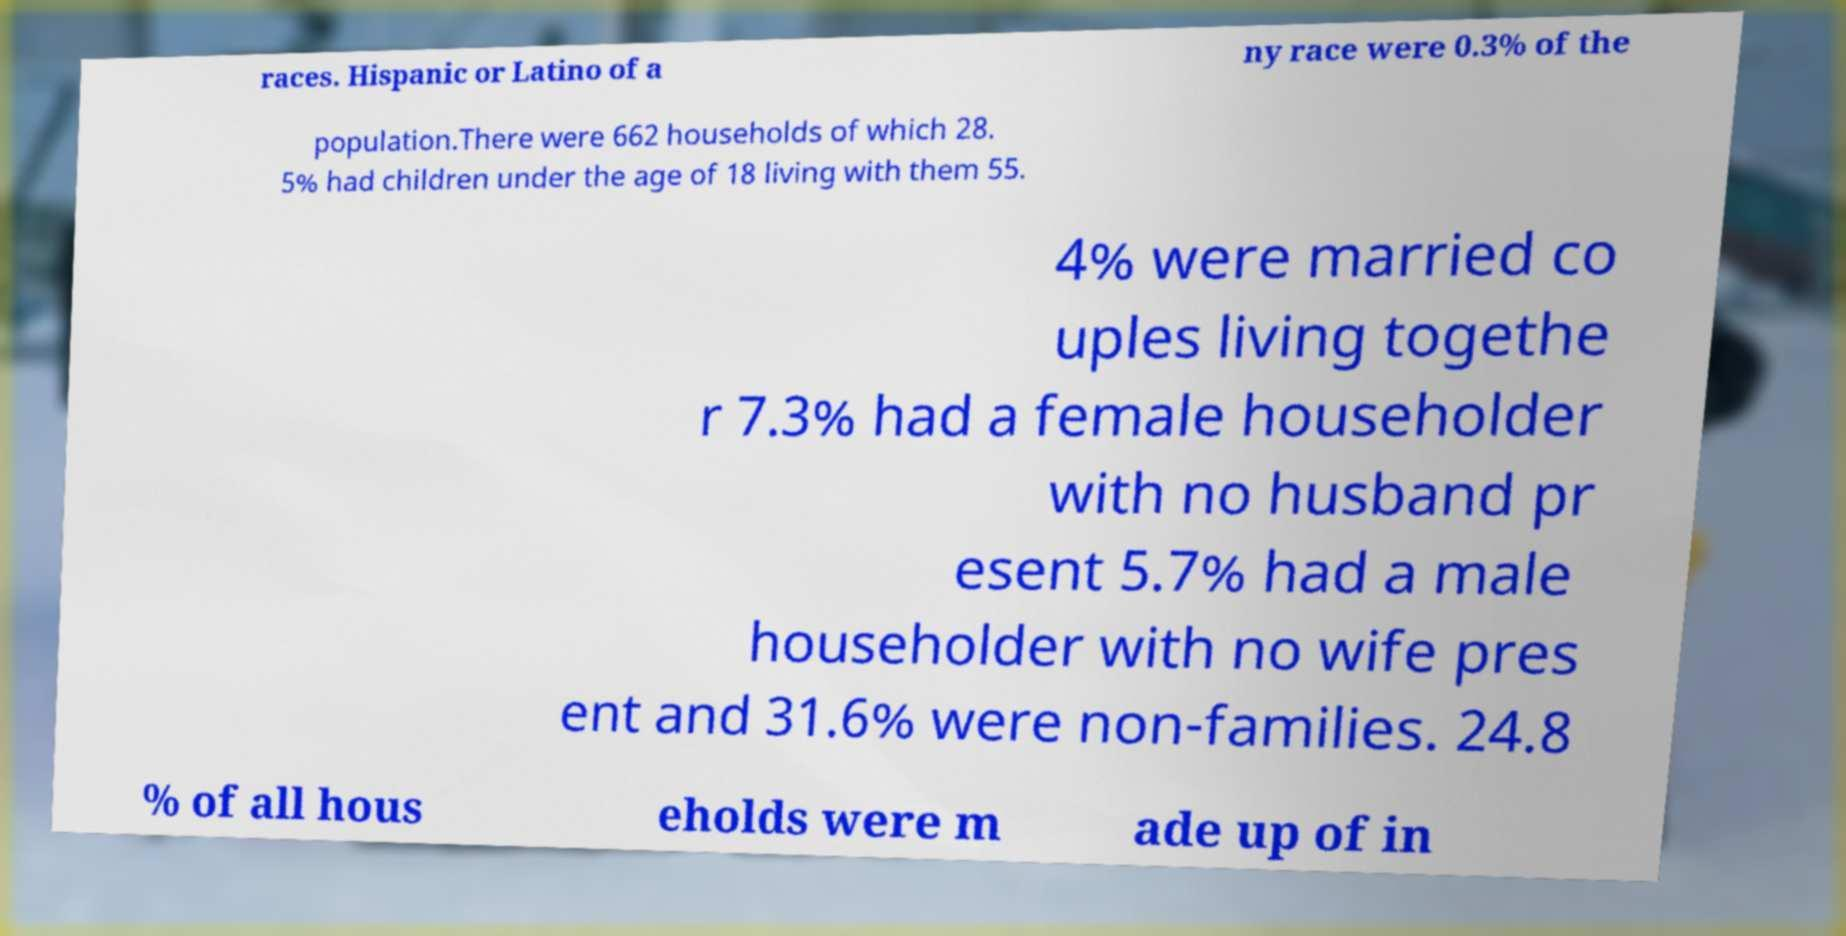For documentation purposes, I need the text within this image transcribed. Could you provide that? races. Hispanic or Latino of a ny race were 0.3% of the population.There were 662 households of which 28. 5% had children under the age of 18 living with them 55. 4% were married co uples living togethe r 7.3% had a female householder with no husband pr esent 5.7% had a male householder with no wife pres ent and 31.6% were non-families. 24.8 % of all hous eholds were m ade up of in 